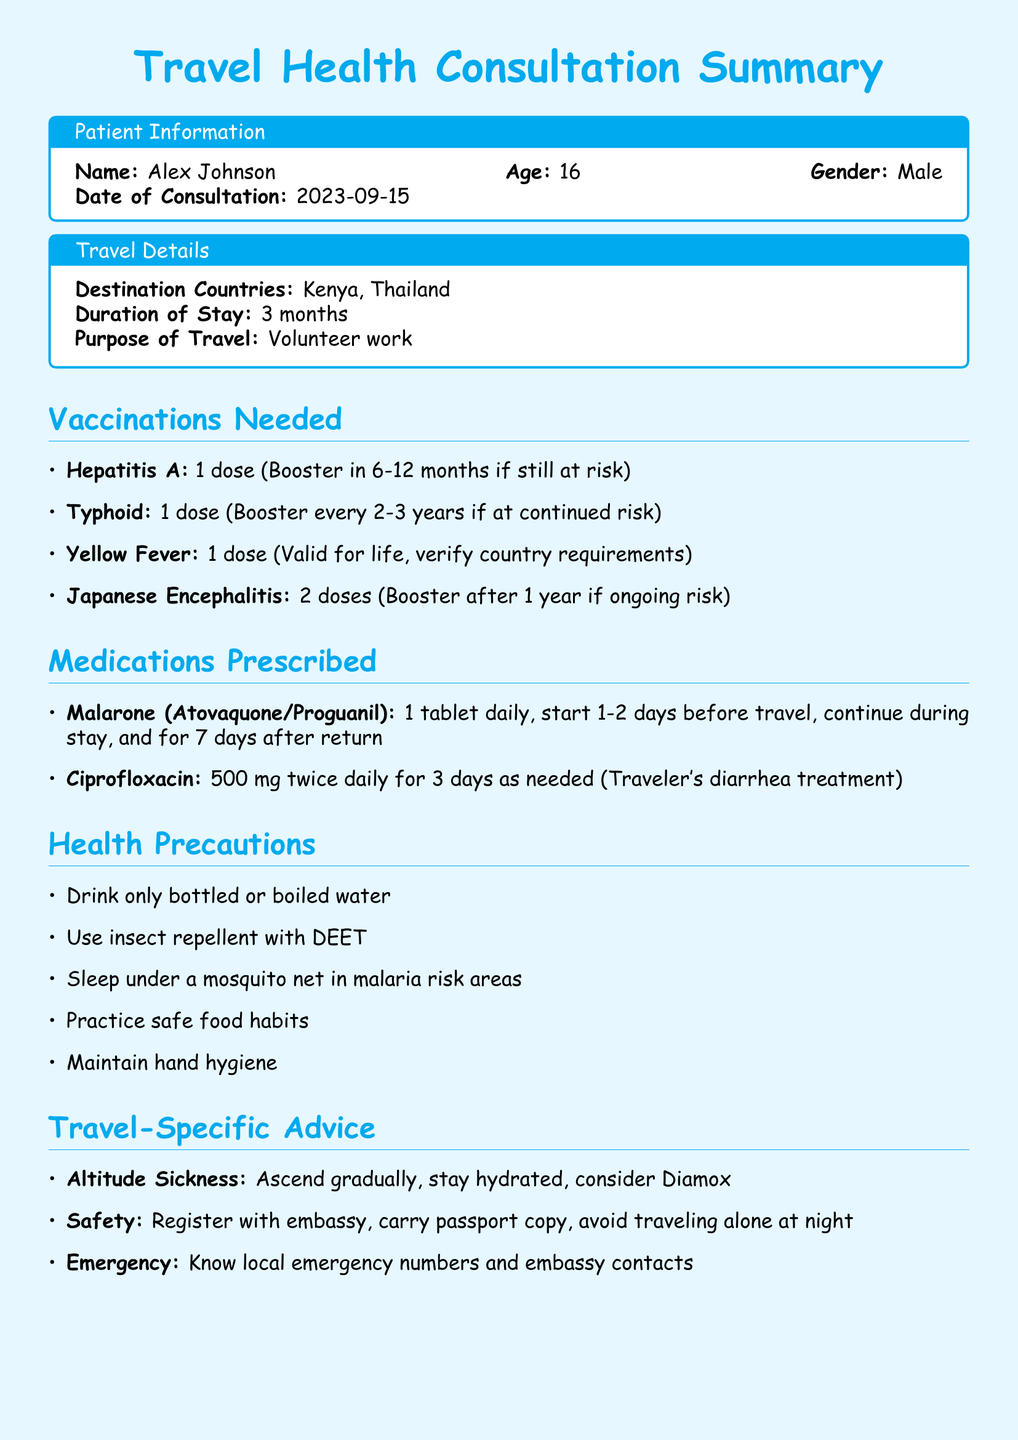What is the patient's name? The name of the patient is provided in the patient information section.
Answer: Alex Johnson What is the purpose of travel? The purpose of travel is specified in the travel details section of the document.
Answer: Volunteer work How long is the duration of stay? The duration of stay is mentioned under travel details.
Answer: 3 months Which vaccine requires a booster every 2-3 years? The document lists vaccinations along with their requirements, specifically highlighting intervals for boosters.
Answer: Typhoid What medication is prescribed for traveler's diarrhea? The medications prescribed section details the medications and their purposes.
Answer: Ciprofloxacin What health precaution should be taken regarding water? Health precautions provide specific advice on water safety during travel.
Answer: Drink only bottled or boiled water What should be done in case of altitude sickness? Travel-specific advice includes recommendations for altitude sickness, requiring action.
Answer: Ascend gradually When should the follow-up for booster doses be scheduled? The follow-up recommendations specify when to schedule for booster doses after travel.
Answer: 6-12 months after return What should be packed according to the notes section? The notes section contains specific advice about packing for the trip.
Answer: Basic first aid kit and personal medications list 